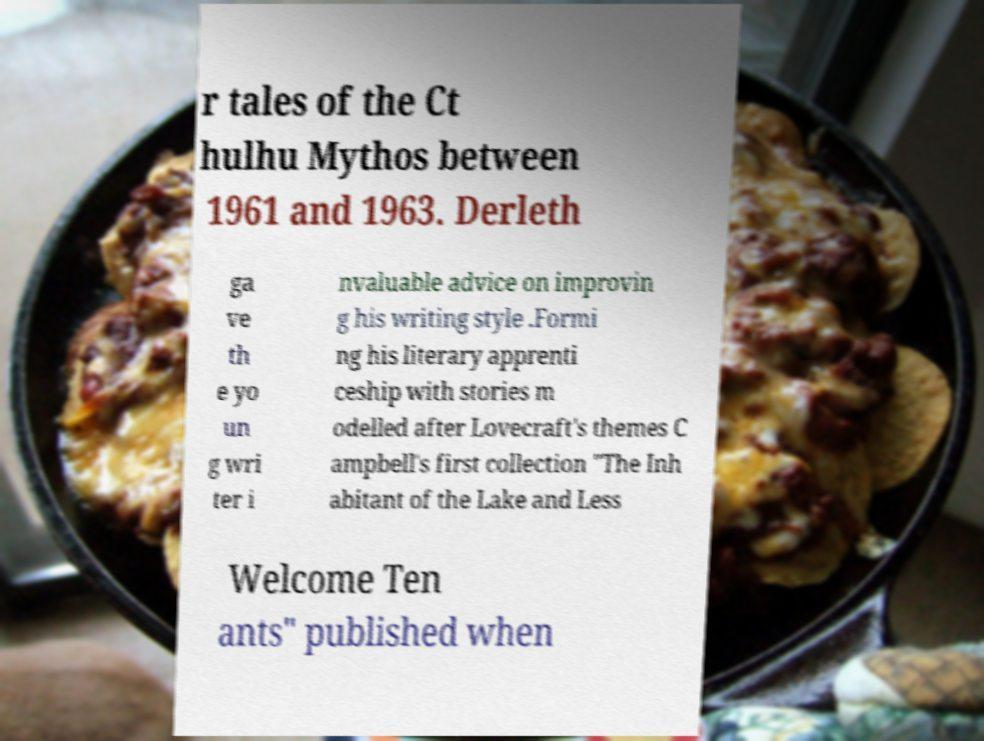Can you read and provide the text displayed in the image?This photo seems to have some interesting text. Can you extract and type it out for me? r tales of the Ct hulhu Mythos between 1961 and 1963. Derleth ga ve th e yo un g wri ter i nvaluable advice on improvin g his writing style .Formi ng his literary apprenti ceship with stories m odelled after Lovecraft's themes C ampbell's first collection "The Inh abitant of the Lake and Less Welcome Ten ants" published when 